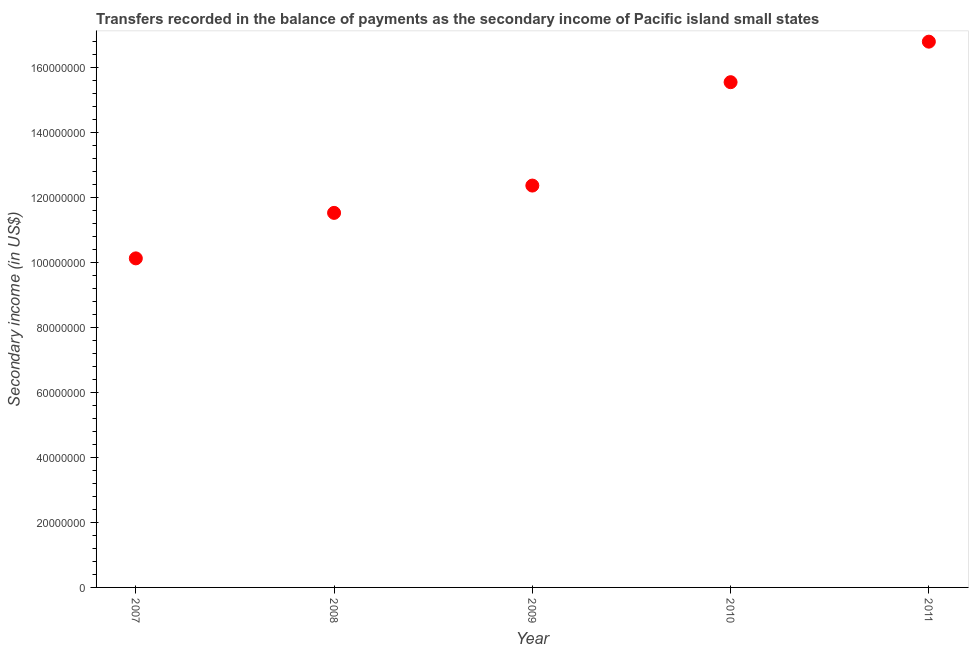What is the amount of secondary income in 2009?
Ensure brevity in your answer.  1.24e+08. Across all years, what is the maximum amount of secondary income?
Ensure brevity in your answer.  1.68e+08. Across all years, what is the minimum amount of secondary income?
Offer a very short reply. 1.01e+08. In which year was the amount of secondary income minimum?
Keep it short and to the point. 2007. What is the sum of the amount of secondary income?
Offer a very short reply. 6.63e+08. What is the difference between the amount of secondary income in 2010 and 2011?
Provide a short and direct response. -1.25e+07. What is the average amount of secondary income per year?
Provide a succinct answer. 1.33e+08. What is the median amount of secondary income?
Offer a terse response. 1.24e+08. What is the ratio of the amount of secondary income in 2009 to that in 2011?
Provide a short and direct response. 0.74. What is the difference between the highest and the second highest amount of secondary income?
Your answer should be very brief. 1.25e+07. Is the sum of the amount of secondary income in 2008 and 2009 greater than the maximum amount of secondary income across all years?
Keep it short and to the point. Yes. What is the difference between the highest and the lowest amount of secondary income?
Your response must be concise. 6.67e+07. In how many years, is the amount of secondary income greater than the average amount of secondary income taken over all years?
Offer a terse response. 2. Does the amount of secondary income monotonically increase over the years?
Give a very brief answer. Yes. How many dotlines are there?
Offer a terse response. 1. How many years are there in the graph?
Provide a succinct answer. 5. What is the difference between two consecutive major ticks on the Y-axis?
Provide a succinct answer. 2.00e+07. Are the values on the major ticks of Y-axis written in scientific E-notation?
Give a very brief answer. No. What is the title of the graph?
Give a very brief answer. Transfers recorded in the balance of payments as the secondary income of Pacific island small states. What is the label or title of the Y-axis?
Your answer should be compact. Secondary income (in US$). What is the Secondary income (in US$) in 2007?
Provide a succinct answer. 1.01e+08. What is the Secondary income (in US$) in 2008?
Offer a terse response. 1.15e+08. What is the Secondary income (in US$) in 2009?
Keep it short and to the point. 1.24e+08. What is the Secondary income (in US$) in 2010?
Your answer should be very brief. 1.55e+08. What is the Secondary income (in US$) in 2011?
Ensure brevity in your answer.  1.68e+08. What is the difference between the Secondary income (in US$) in 2007 and 2008?
Offer a very short reply. -1.40e+07. What is the difference between the Secondary income (in US$) in 2007 and 2009?
Offer a very short reply. -2.24e+07. What is the difference between the Secondary income (in US$) in 2007 and 2010?
Provide a short and direct response. -5.42e+07. What is the difference between the Secondary income (in US$) in 2007 and 2011?
Make the answer very short. -6.67e+07. What is the difference between the Secondary income (in US$) in 2008 and 2009?
Provide a succinct answer. -8.40e+06. What is the difference between the Secondary income (in US$) in 2008 and 2010?
Keep it short and to the point. -4.02e+07. What is the difference between the Secondary income (in US$) in 2008 and 2011?
Your response must be concise. -5.27e+07. What is the difference between the Secondary income (in US$) in 2009 and 2010?
Make the answer very short. -3.18e+07. What is the difference between the Secondary income (in US$) in 2009 and 2011?
Ensure brevity in your answer.  -4.43e+07. What is the difference between the Secondary income (in US$) in 2010 and 2011?
Your response must be concise. -1.25e+07. What is the ratio of the Secondary income (in US$) in 2007 to that in 2008?
Your response must be concise. 0.88. What is the ratio of the Secondary income (in US$) in 2007 to that in 2009?
Keep it short and to the point. 0.82. What is the ratio of the Secondary income (in US$) in 2007 to that in 2010?
Make the answer very short. 0.65. What is the ratio of the Secondary income (in US$) in 2007 to that in 2011?
Provide a succinct answer. 0.6. What is the ratio of the Secondary income (in US$) in 2008 to that in 2009?
Your answer should be compact. 0.93. What is the ratio of the Secondary income (in US$) in 2008 to that in 2010?
Your response must be concise. 0.74. What is the ratio of the Secondary income (in US$) in 2008 to that in 2011?
Your answer should be compact. 0.69. What is the ratio of the Secondary income (in US$) in 2009 to that in 2010?
Keep it short and to the point. 0.8. What is the ratio of the Secondary income (in US$) in 2009 to that in 2011?
Your answer should be very brief. 0.74. What is the ratio of the Secondary income (in US$) in 2010 to that in 2011?
Your answer should be very brief. 0.93. 